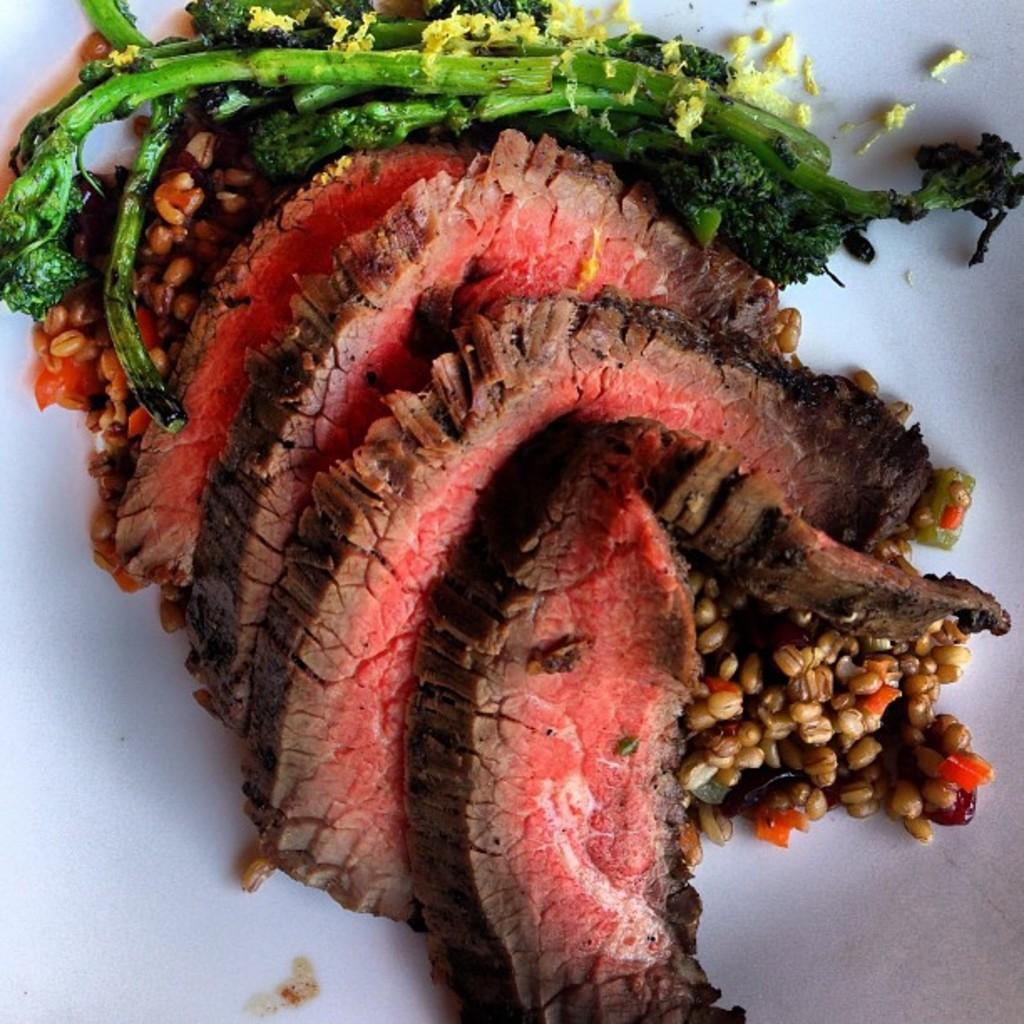Can you describe this image briefly? In this image I can see the food on the white color surface. I can see the food is in green, yellow, red and brown color. 